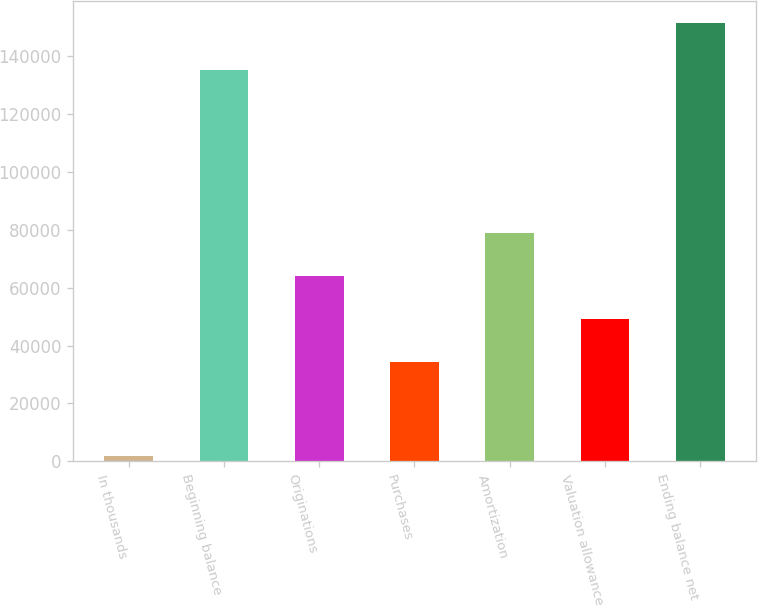Convert chart. <chart><loc_0><loc_0><loc_500><loc_500><bar_chart><fcel>In thousands<fcel>Beginning balance<fcel>Originations<fcel>Purchases<fcel>Amortization<fcel>Valuation allowance<fcel>Ending balance net<nl><fcel>2003<fcel>135076<fcel>64105.6<fcel>34243<fcel>79036.9<fcel>49174.3<fcel>151316<nl></chart> 